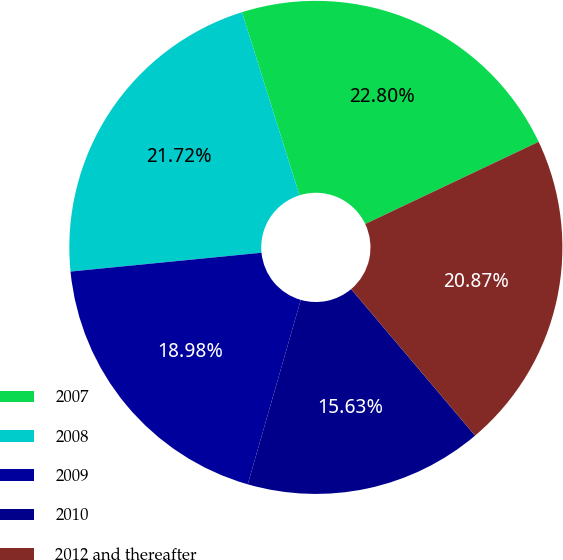Convert chart. <chart><loc_0><loc_0><loc_500><loc_500><pie_chart><fcel>2007<fcel>2008<fcel>2009<fcel>2010<fcel>2012 and thereafter<nl><fcel>22.8%<fcel>21.72%<fcel>18.98%<fcel>15.63%<fcel>20.87%<nl></chart> 